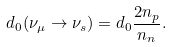<formula> <loc_0><loc_0><loc_500><loc_500>d _ { 0 } ( \nu _ { \mu } \rightarrow \nu _ { s } ) = d _ { 0 } { \frac { 2 n _ { p } } { n _ { n } } } .</formula> 